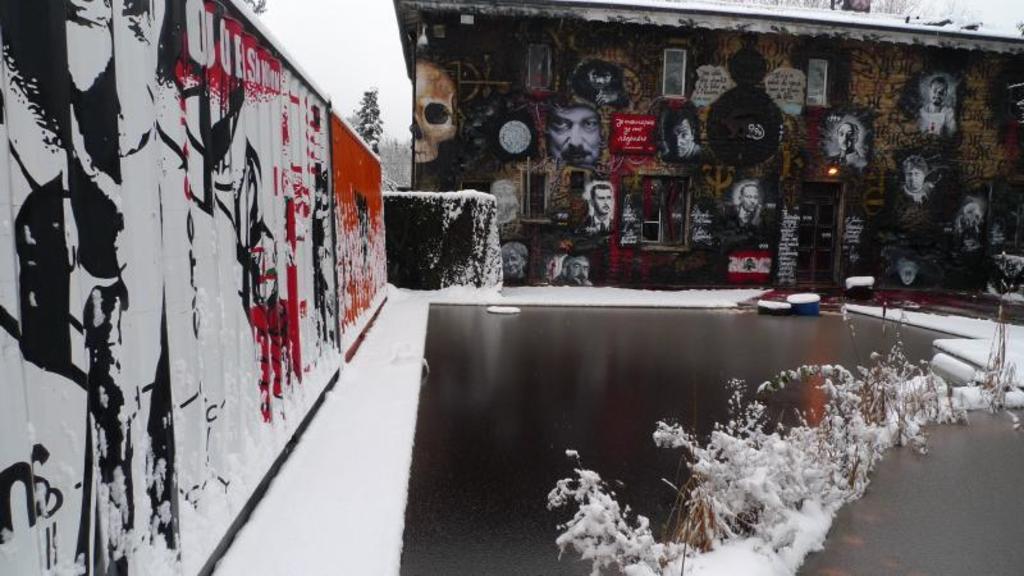Please provide a concise description of this image. In this image I can see the wall on the left side on the wall I can see a colorful painting in the middle I can see a water and the snow and at the top I can see the wall ,on the wall I can see persons images. 